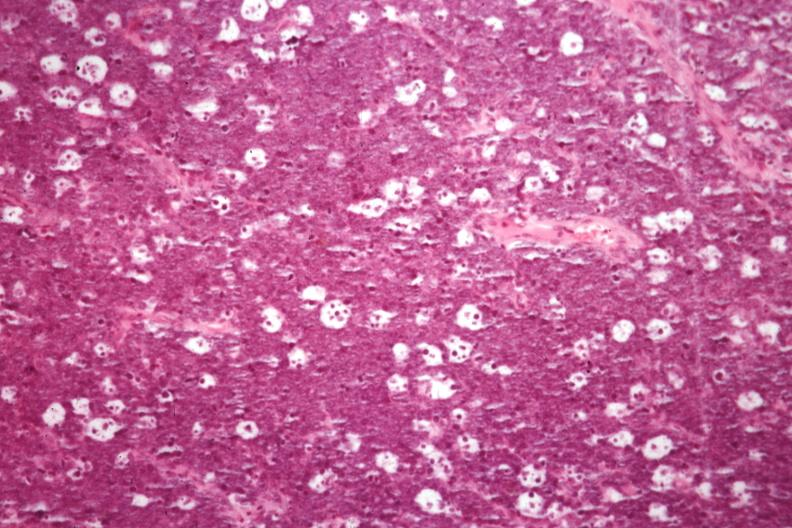what is present?
Answer the question using a single word or phrase. Burkitts lymphoma 